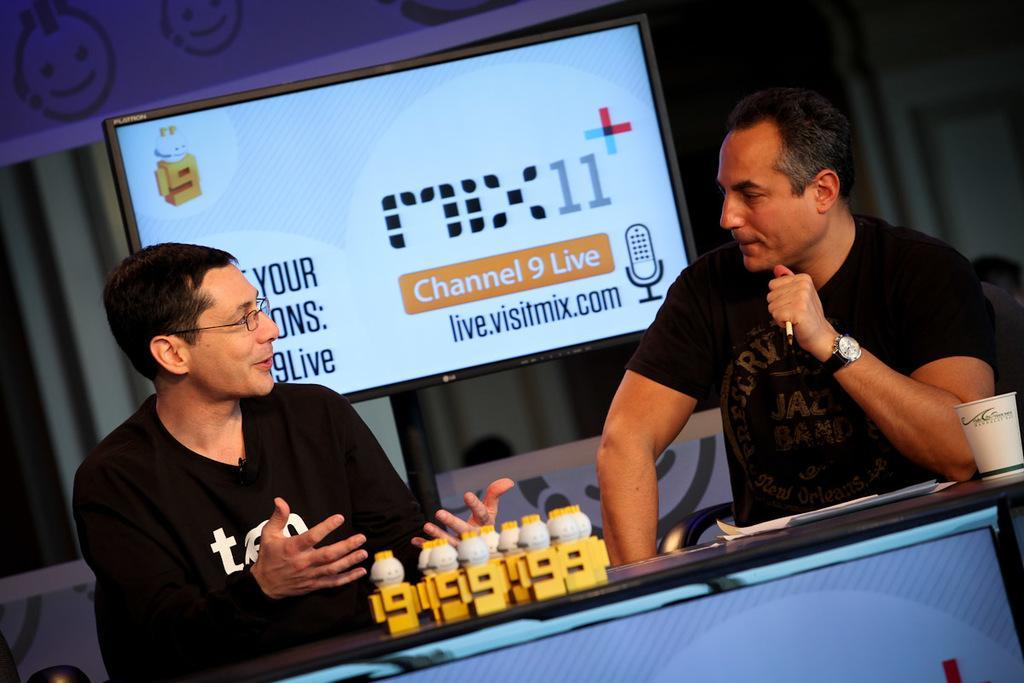Describe this image in one or two sentences. This picture shows couple of them seated on the chairs and we see few toys and a cup and few papers on the table and we see a television on the back and we see a man wore spectacles on his face. Both of them wore black color t-shirts. 